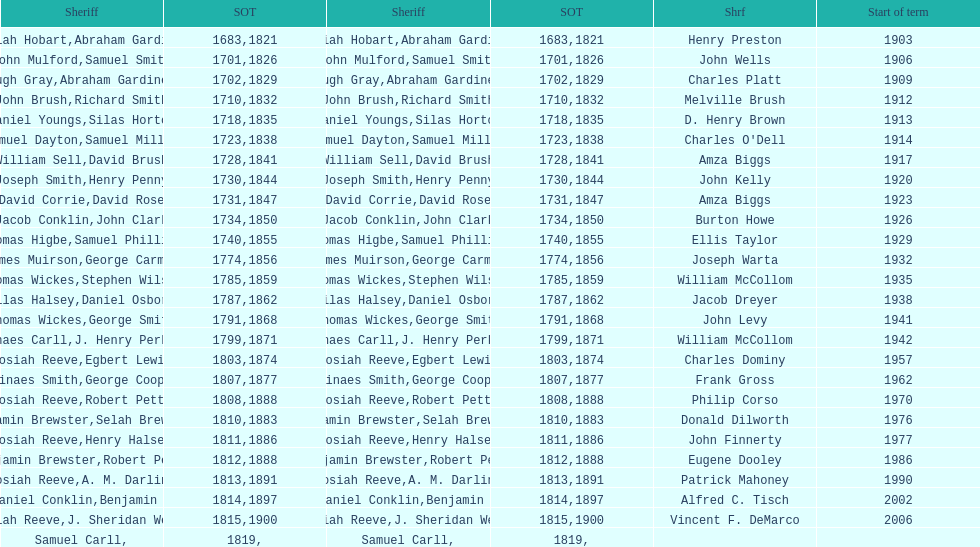How many sheriff's have the last name biggs? 1. 